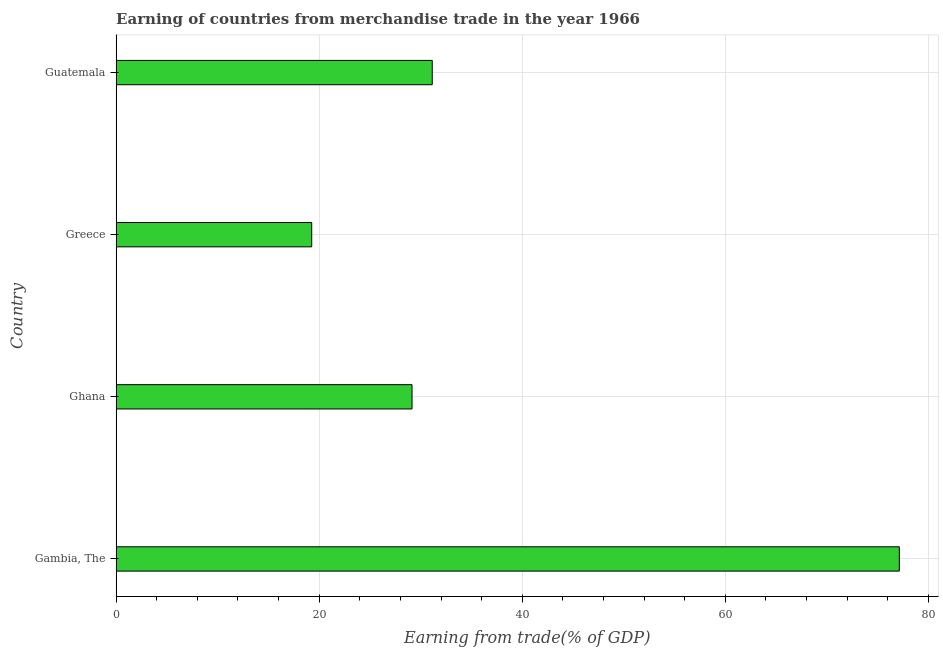Does the graph contain any zero values?
Your response must be concise. No. What is the title of the graph?
Provide a short and direct response. Earning of countries from merchandise trade in the year 1966. What is the label or title of the X-axis?
Your response must be concise. Earning from trade(% of GDP). What is the label or title of the Y-axis?
Provide a short and direct response. Country. What is the earning from merchandise trade in Ghana?
Offer a very short reply. 29.14. Across all countries, what is the maximum earning from merchandise trade?
Make the answer very short. 77.14. Across all countries, what is the minimum earning from merchandise trade?
Your answer should be compact. 19.26. In which country was the earning from merchandise trade maximum?
Provide a succinct answer. Gambia, The. In which country was the earning from merchandise trade minimum?
Provide a succinct answer. Greece. What is the sum of the earning from merchandise trade?
Your answer should be compact. 156.68. What is the difference between the earning from merchandise trade in Gambia, The and Guatemala?
Offer a terse response. 46. What is the average earning from merchandise trade per country?
Your response must be concise. 39.17. What is the median earning from merchandise trade?
Give a very brief answer. 30.14. In how many countries, is the earning from merchandise trade greater than 24 %?
Give a very brief answer. 3. What is the ratio of the earning from merchandise trade in Ghana to that in Greece?
Ensure brevity in your answer.  1.51. Is the difference between the earning from merchandise trade in Gambia, The and Greece greater than the difference between any two countries?
Your answer should be compact. Yes. What is the difference between the highest and the second highest earning from merchandise trade?
Provide a succinct answer. 46. What is the difference between the highest and the lowest earning from merchandise trade?
Give a very brief answer. 57.87. In how many countries, is the earning from merchandise trade greater than the average earning from merchandise trade taken over all countries?
Provide a short and direct response. 1. How many bars are there?
Provide a succinct answer. 4. What is the Earning from trade(% of GDP) in Gambia, The?
Your answer should be very brief. 77.14. What is the Earning from trade(% of GDP) in Ghana?
Provide a succinct answer. 29.14. What is the Earning from trade(% of GDP) in Greece?
Your answer should be compact. 19.26. What is the Earning from trade(% of GDP) of Guatemala?
Give a very brief answer. 31.13. What is the difference between the Earning from trade(% of GDP) in Gambia, The and Ghana?
Offer a very short reply. 47.99. What is the difference between the Earning from trade(% of GDP) in Gambia, The and Greece?
Your answer should be very brief. 57.87. What is the difference between the Earning from trade(% of GDP) in Gambia, The and Guatemala?
Provide a short and direct response. 46. What is the difference between the Earning from trade(% of GDP) in Ghana and Greece?
Your answer should be very brief. 9.88. What is the difference between the Earning from trade(% of GDP) in Ghana and Guatemala?
Give a very brief answer. -1.99. What is the difference between the Earning from trade(% of GDP) in Greece and Guatemala?
Provide a short and direct response. -11.87. What is the ratio of the Earning from trade(% of GDP) in Gambia, The to that in Ghana?
Provide a short and direct response. 2.65. What is the ratio of the Earning from trade(% of GDP) in Gambia, The to that in Greece?
Offer a terse response. 4. What is the ratio of the Earning from trade(% of GDP) in Gambia, The to that in Guatemala?
Provide a succinct answer. 2.48. What is the ratio of the Earning from trade(% of GDP) in Ghana to that in Greece?
Ensure brevity in your answer.  1.51. What is the ratio of the Earning from trade(% of GDP) in Ghana to that in Guatemala?
Give a very brief answer. 0.94. What is the ratio of the Earning from trade(% of GDP) in Greece to that in Guatemala?
Keep it short and to the point. 0.62. 